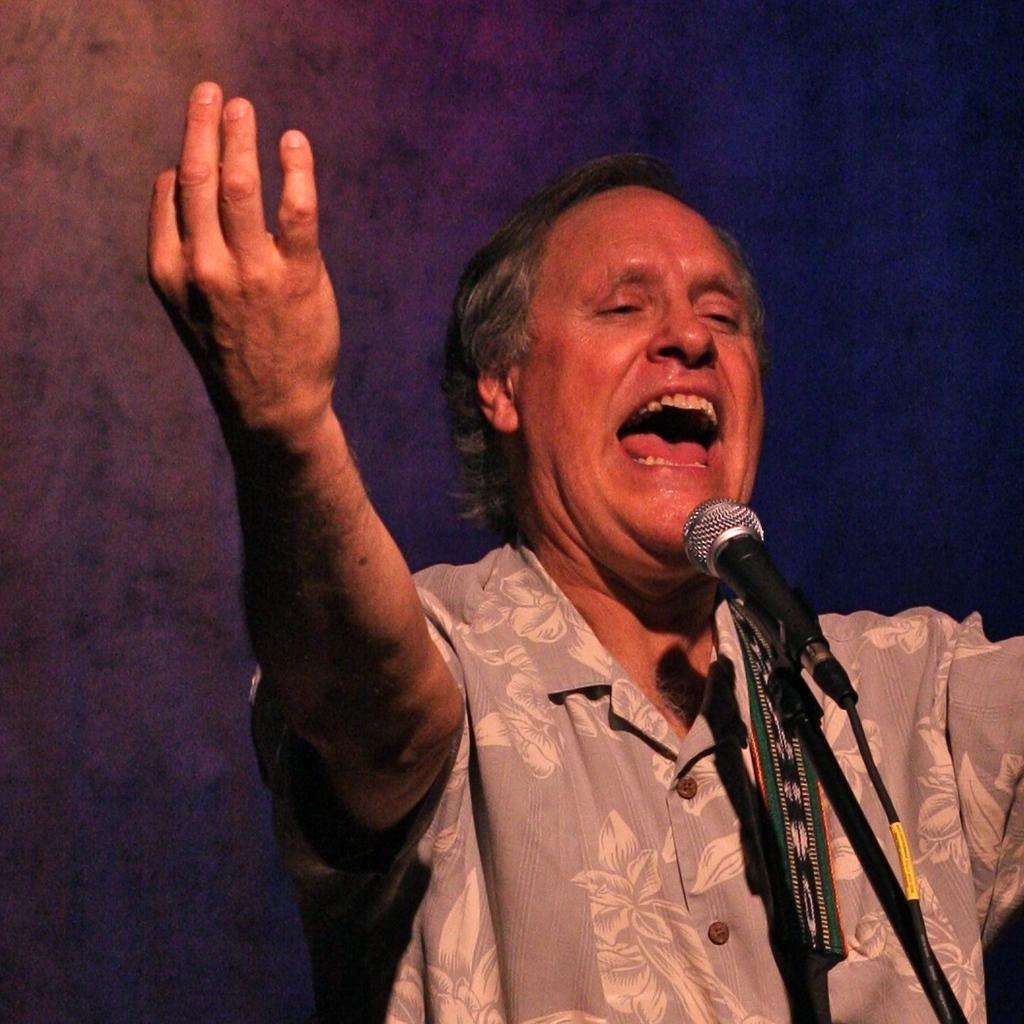Who is present in the image? There is a person in the image. What is the person wearing? The person is wearing a shirt. What object can be seen in the image related to sound? There is a microphone in the image. How is the microphone positioned in the image? The microphone is placed on a stand. Where is the person standing in relation to the microphone? The person is standing in front of the microphone. Can you see the person's friend in the image? There is no mention of a friend in the image, so we cannot determine if a friend is present. 